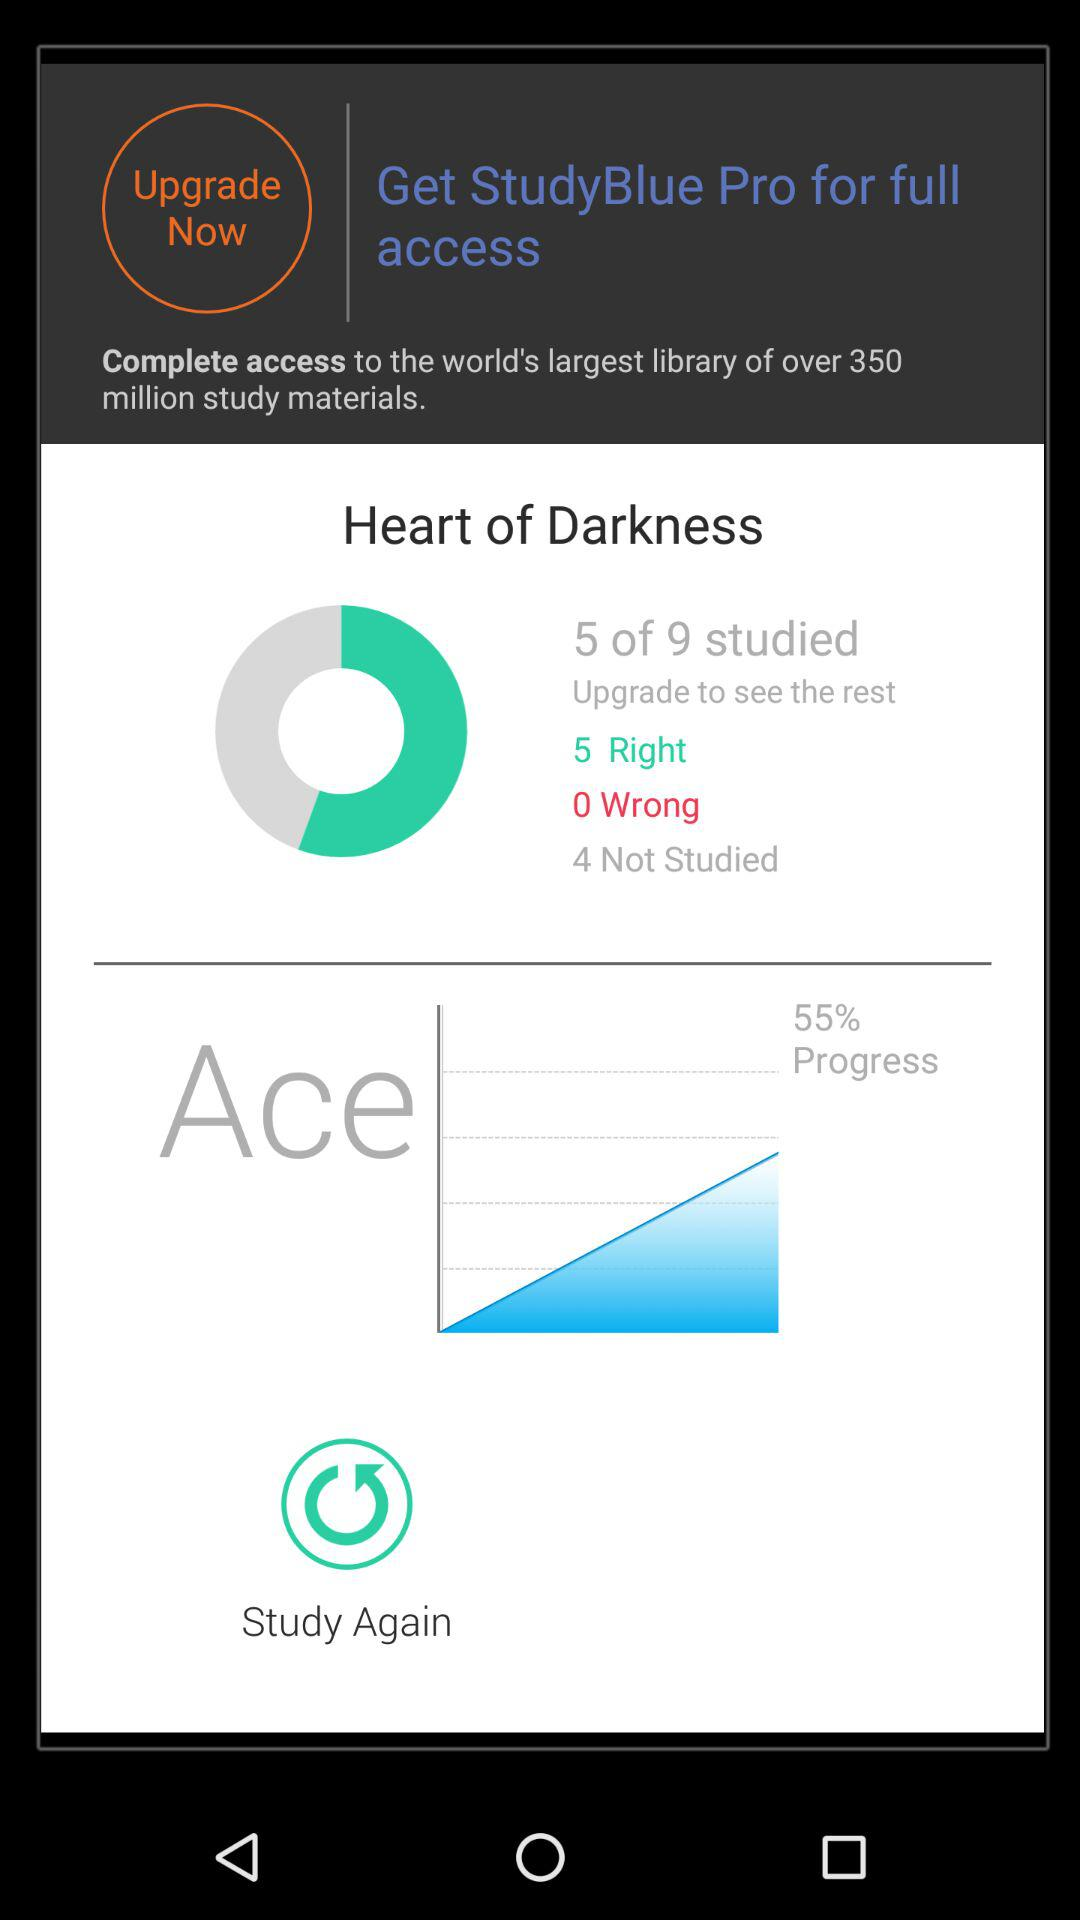How many more questions have been studied than not studied?
Answer the question using a single word or phrase. 1 